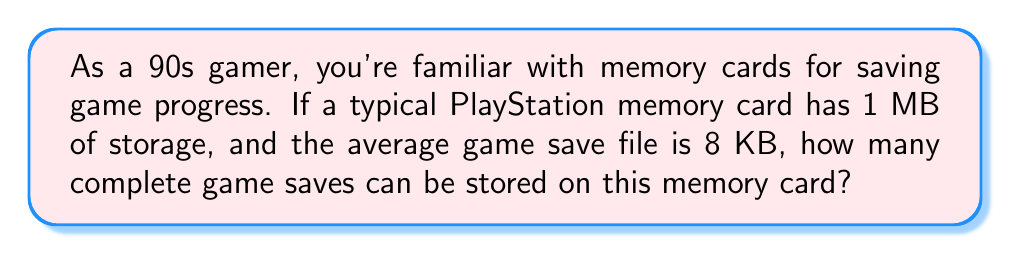Could you help me with this problem? To solve this problem, we need to convert the storage units to the same scale and then perform a division. Let's break it down step-by-step:

1. Convert 1 MB to KB:
   $1 \text{ MB} = 1024 \text{ KB}$

2. Set up the division:
   $$\text{Number of saves} = \frac{\text{Total storage}}{\text{Size of one save}}$$

3. Plug in the values:
   $$\text{Number of saves} = \frac{1024 \text{ KB}}{8 \text{ KB}}$$

4. Perform the division:
   $$\text{Number of saves} = 128$$

Since we can't have a partial save file, we round down to the nearest whole number.

This result means that a 1 MB memory card can store 128 complete game saves of 8 KB each.
Answer: 128 complete game saves 